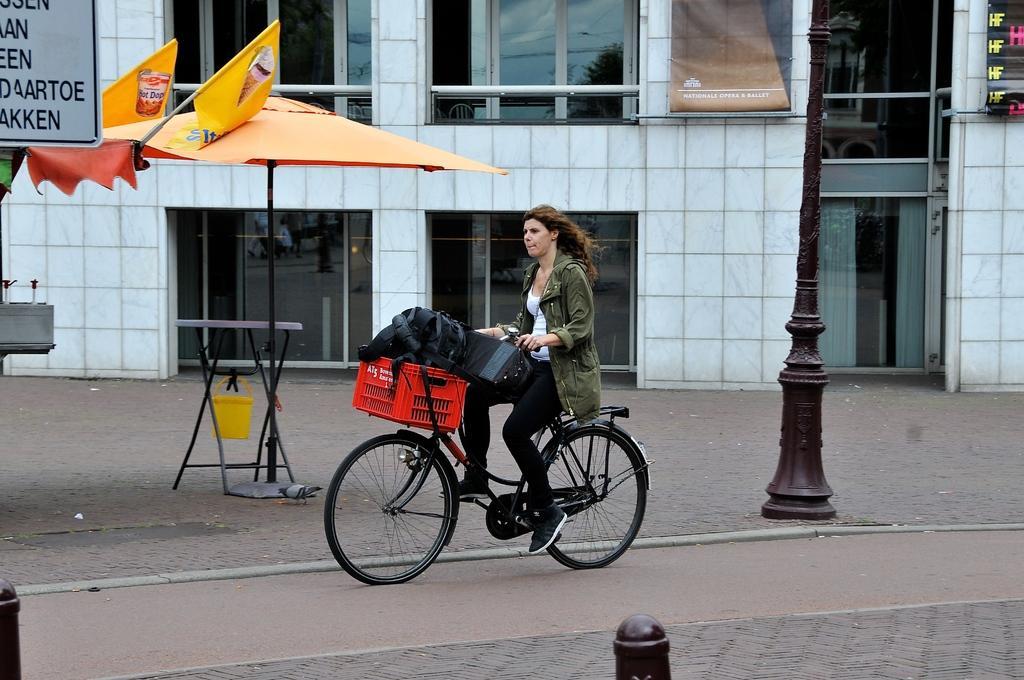Could you give a brief overview of what you see in this image? In this image i can see a woman is cycling a bicycle on the road. I can see there is a building, a tent and a pole. 